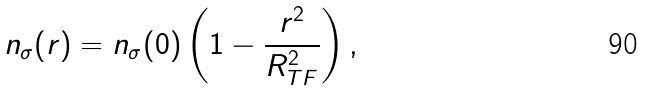Convert formula to latex. <formula><loc_0><loc_0><loc_500><loc_500>n _ { \sigma } ( { r } ) = n _ { \sigma } ( 0 ) \left ( 1 - \frac { r ^ { 2 } } { R _ { T F } ^ { 2 } } \right ) ,</formula> 